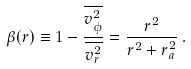<formula> <loc_0><loc_0><loc_500><loc_500>\beta ( r ) \equiv 1 - \frac { \overline { v _ { \phi } ^ { 2 } } } { \overline { v _ { r } ^ { 2 } } } = \frac { r ^ { 2 } } { r ^ { 2 } + r _ { a } ^ { 2 } } \, .</formula> 